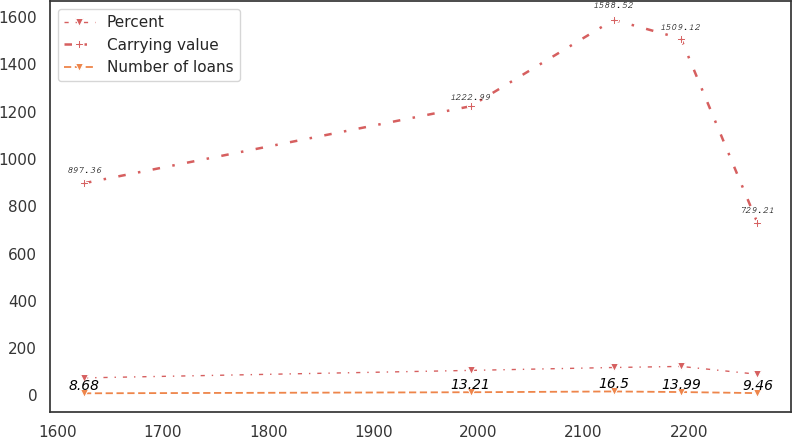<chart> <loc_0><loc_0><loc_500><loc_500><line_chart><ecel><fcel>Percent<fcel>Carrying value<fcel>Number of loans<nl><fcel>1624.85<fcel>73.87<fcel>897.36<fcel>8.68<nl><fcel>1992.6<fcel>105.59<fcel>1222.99<fcel>13.21<nl><fcel>2128.53<fcel>117.84<fcel>1588.52<fcel>16.5<nl><fcel>2192.58<fcel>122.37<fcel>1509.12<fcel>13.99<nl><fcel>2265.39<fcel>89.3<fcel>729.21<fcel>9.46<nl></chart> 